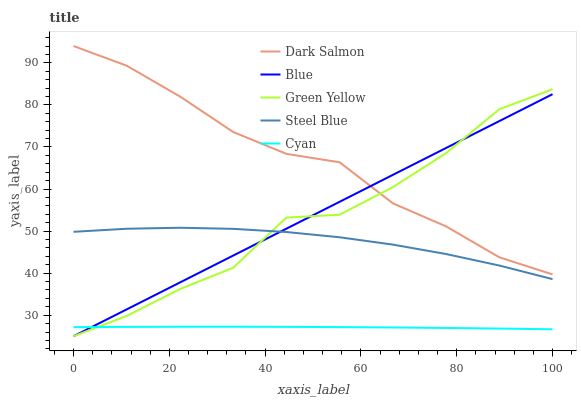Does Cyan have the minimum area under the curve?
Answer yes or no. Yes. Does Dark Salmon have the maximum area under the curve?
Answer yes or no. Yes. Does Green Yellow have the minimum area under the curve?
Answer yes or no. No. Does Green Yellow have the maximum area under the curve?
Answer yes or no. No. Is Blue the smoothest?
Answer yes or no. Yes. Is Green Yellow the roughest?
Answer yes or no. Yes. Is Cyan the smoothest?
Answer yes or no. No. Is Cyan the roughest?
Answer yes or no. No. Does Blue have the lowest value?
Answer yes or no. Yes. Does Cyan have the lowest value?
Answer yes or no. No. Does Dark Salmon have the highest value?
Answer yes or no. Yes. Does Green Yellow have the highest value?
Answer yes or no. No. Is Cyan less than Steel Blue?
Answer yes or no. Yes. Is Dark Salmon greater than Cyan?
Answer yes or no. Yes. Does Green Yellow intersect Steel Blue?
Answer yes or no. Yes. Is Green Yellow less than Steel Blue?
Answer yes or no. No. Is Green Yellow greater than Steel Blue?
Answer yes or no. No. Does Cyan intersect Steel Blue?
Answer yes or no. No. 